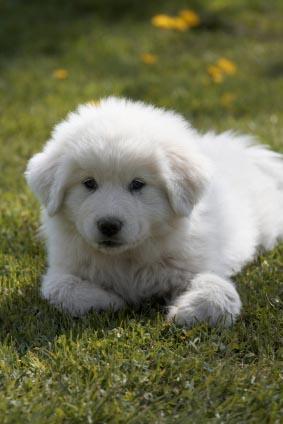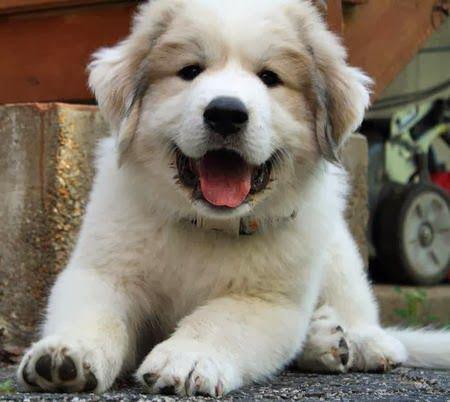The first image is the image on the left, the second image is the image on the right. Assess this claim about the two images: "An image shows a fluffy dog reclining on the grass.". Correct or not? Answer yes or no. Yes. 